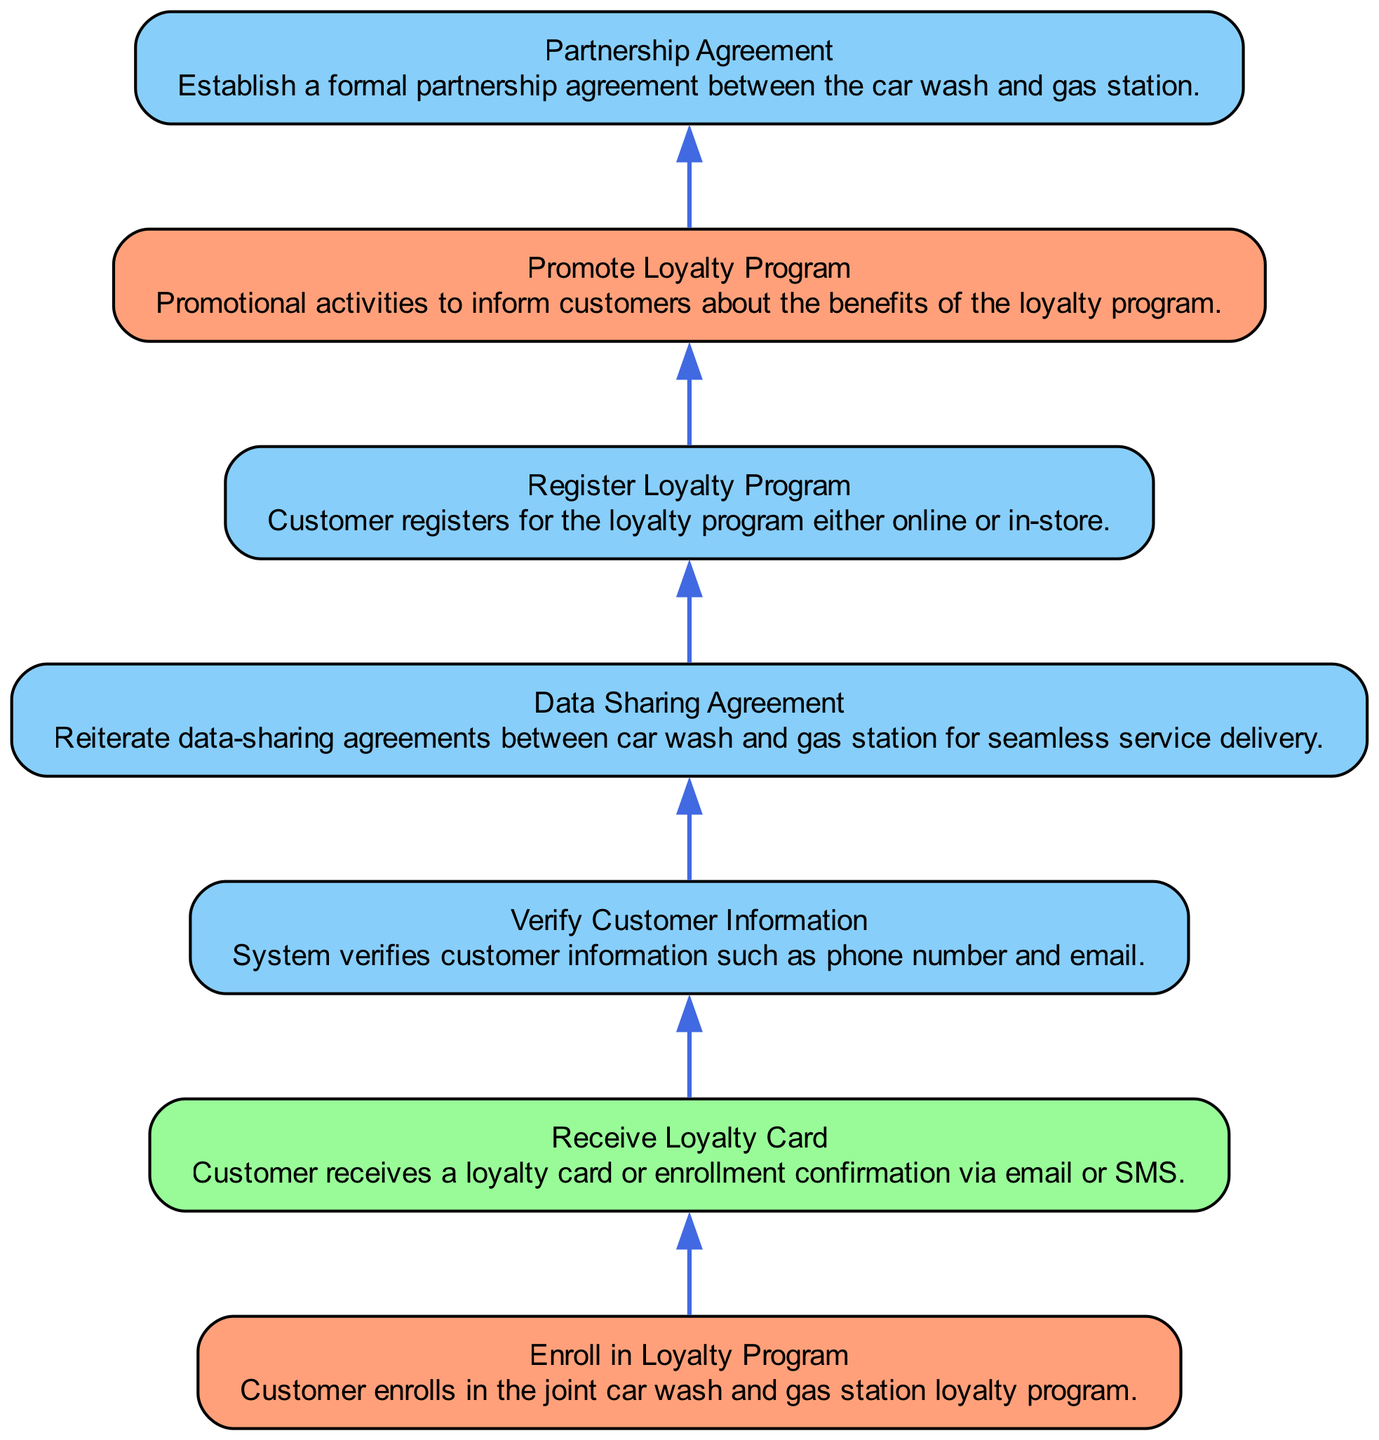What is the first step in the enrollment process? The first step in the diagram is "Enroll in Loyalty Program," as it is the bottom node, indicating the starting action in the workflow.
Answer: Enroll in Loyalty Program How many total nodes are there in the diagram? By counting all the elements in the data provided (enrollment, issuing card, customer verification, etc.), there are seven distinct nodes representing different steps in the workflow.
Answer: 7 What is the output of the enrollment process? The output from the diagram is "Receive Loyalty Card," which indicates that after completing the process, the customer receives confirmation via card or message.
Answer: Receive Loyalty Card Which two processes occur after the customer verifies their information? Following the "Verify Customer Information," the next two processes are "Register Loyalty Program" and "Data Sharing Agreement," as depicted in sequential order in the flowchart.
Answer: Register Loyalty Program, Data Sharing Agreement What type of agreement needs to be established for the loyalty program? The diagram specifies that a "Partnership Agreement" must be established between the car wash and gas station, which is necessary for the collaboration on the loyalty program.
Answer: Partnership Agreement Which nodes are classified as actions? The nodes identified as actions in the diagram are "Enroll in Loyalty Program" and "Promote Loyalty Program," as they are marked as action types according to the element classifications.
Answer: Enroll in Loyalty Program, Promote Loyalty Program What is the sequence of processes that occur before the customer receives their loyalty card? The sequence includes "Verify Customer Information," "Register Loyalty Program," and "Data Sharing Agreement," all processes that must be completed before the issuance of the loyalty card.
Answer: Verify Customer Information, Register Loyalty Program, Data Sharing Agreement What is the last step a customer goes through in the workflow? The last step indicated in the flowchart is "Receive Loyalty Card," which represents the final outcome of the entire enrollment process in the loyalty program.
Answer: Receive Loyalty Card 